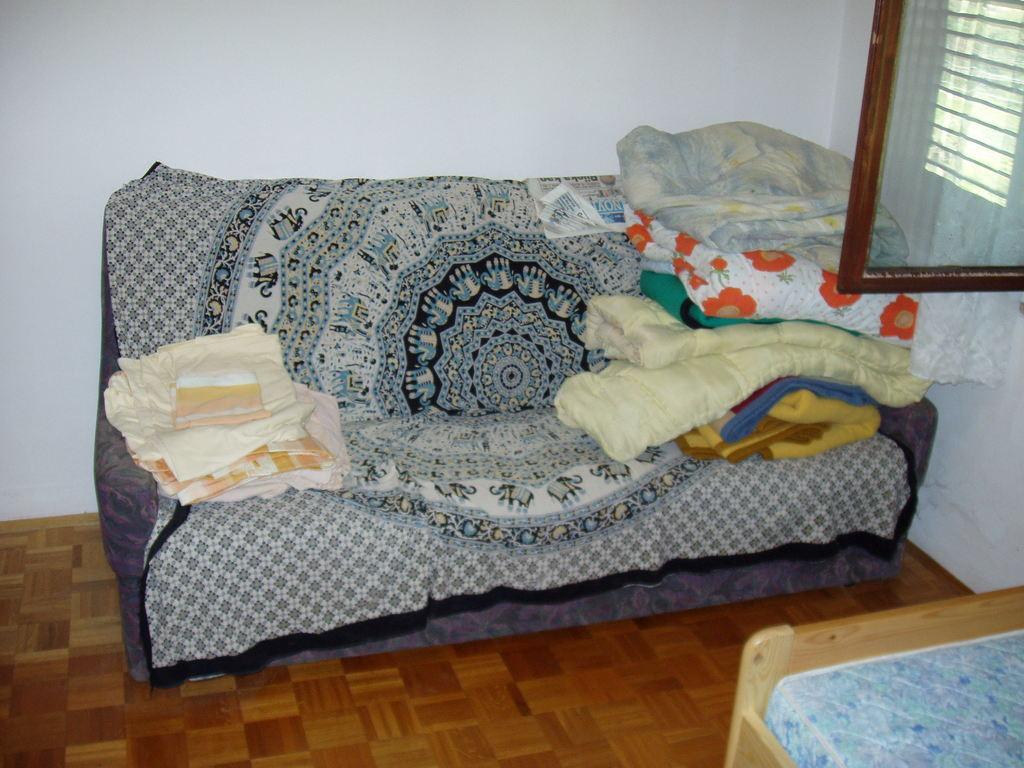Could you give a brief overview of what you see in this image? As we can see in the image there is white color wall, window, sofa, table and there are bed sheets. 